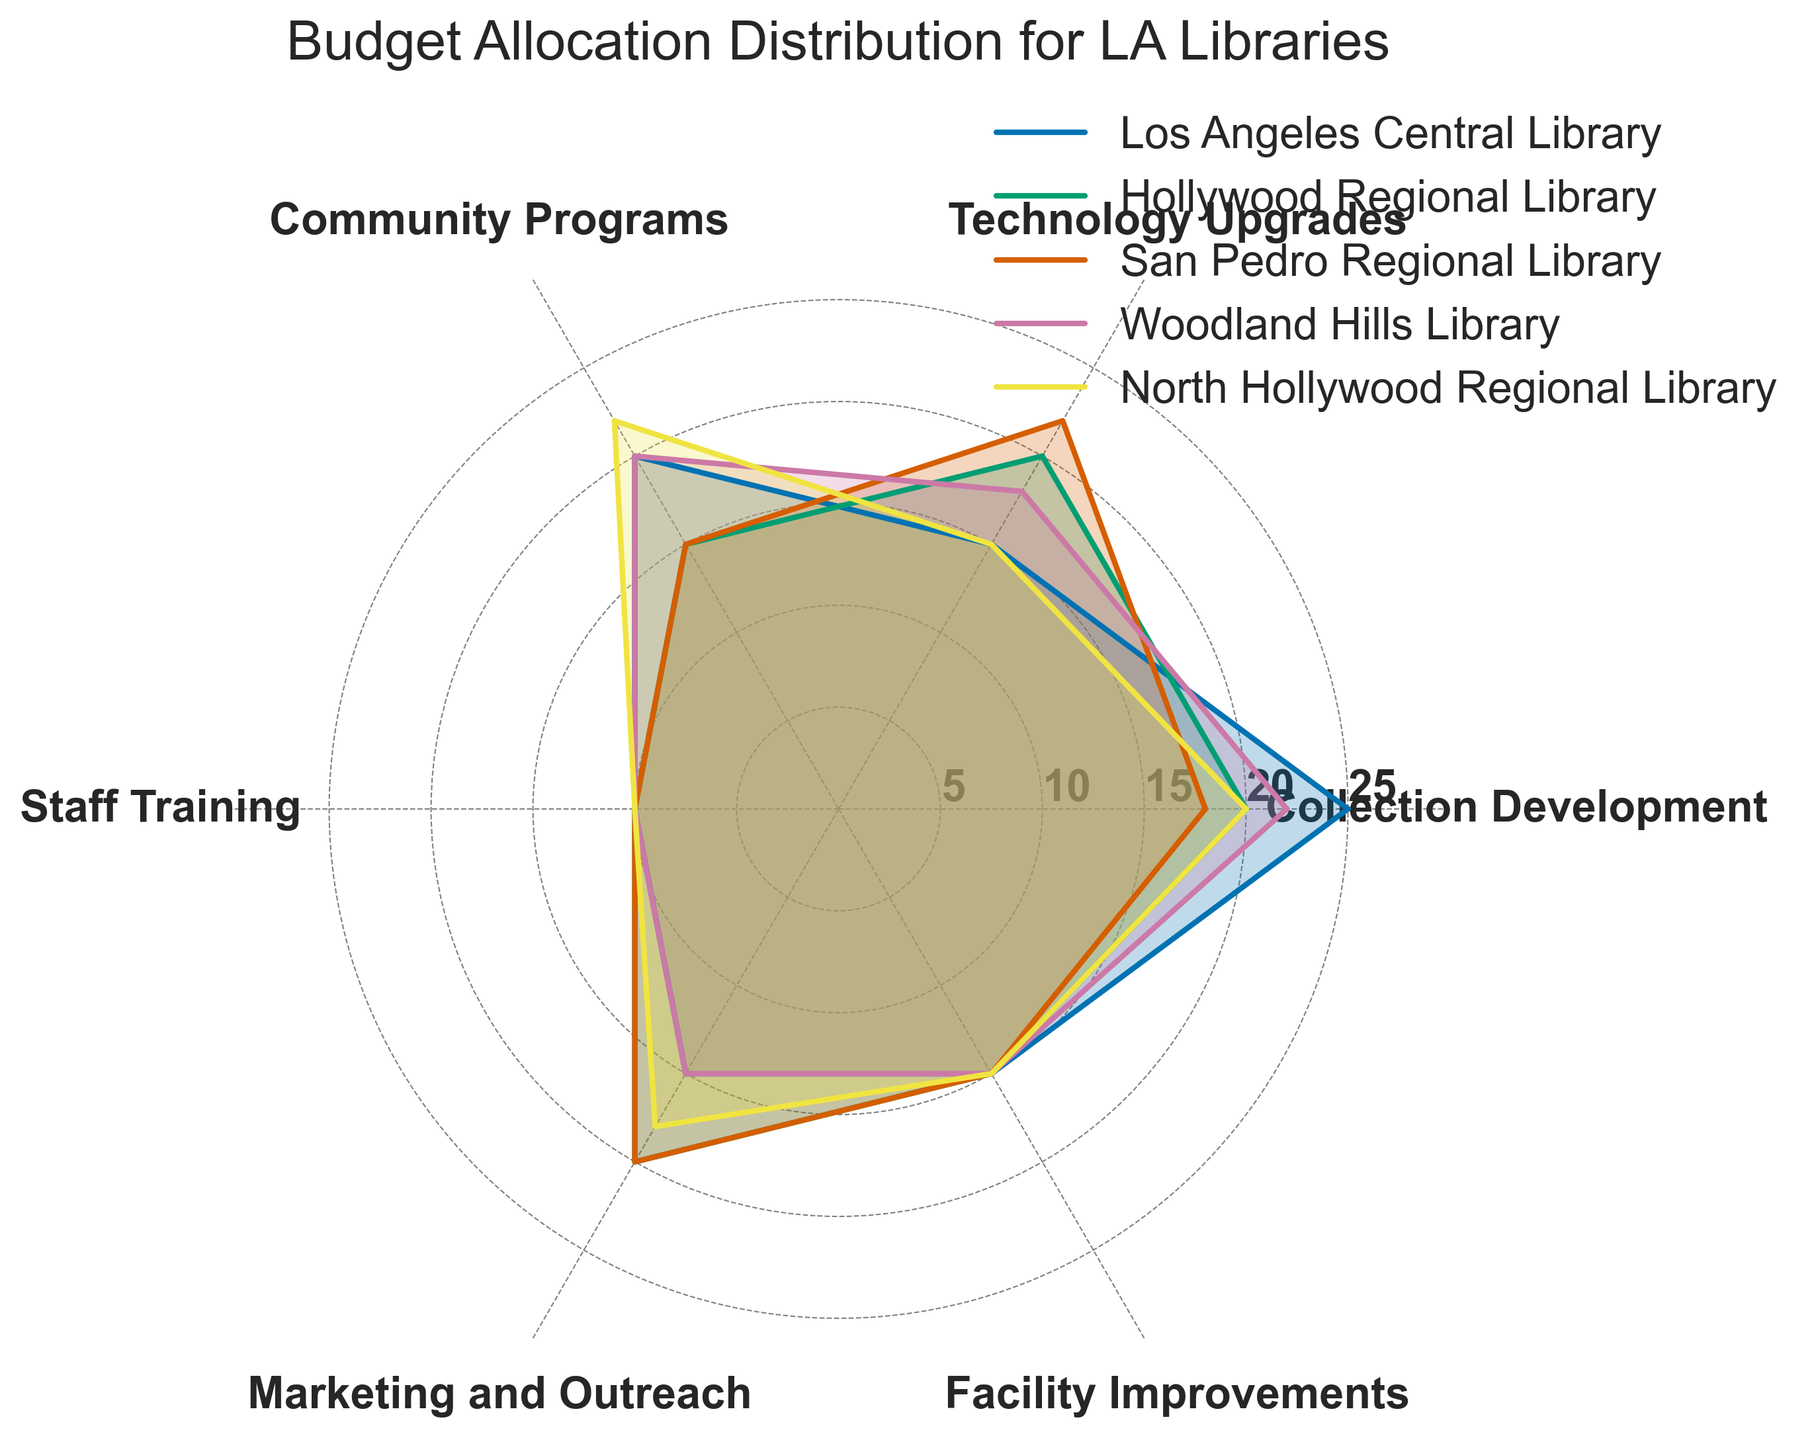What's the overall title of the radar chart? The title of the radar chart is prominently displayed at the top of the figure. It summarizes the main focus of the data presented in the chart.
Answer: Budget Allocation Distribution for LA Libraries Which library has the highest allocation for Community Programs? Look at the sections labeled 'Community Programs' and compare the values for each library. The highest allocation can be determined by the longest line extending from the center in that section.
Answer: North Hollywood Regional Library Which two categories have the same allocation for all libraries? Examine each category and their respective values across all libraries. Identify the categories where the line lengths are identical for every library in those sections.
Answer: Staff Training and Facility Improvements What is the average budget allocation for Technology Upgrades across all libraries? Calculate the average by summing up the budget allocations for Technology Upgrades from all libraries and dividing by the number of libraries. (15+20+22+18+15)/5 = 18
Answer: 18 Which library allocates the most to Marketing and Outreach? Compare the Marketing and Outreach sections and identify which library has the longest line extending in that category.
Answer: Hollywood Regional Library and San Pedro Regional Library For Woodland Hills Library, which two categories have the highest allocations? Look at the Woodland Hills Library's allocations and identify the two categories with the longest line segments.
Answer: Collection Development and Community Programs Between Los Angeles Central Library and Hollywood Regional Library, which one allocates more budget to Technology Upgrades? Compare the lengths of the line segments for Technology Upgrades for these two libraries.
Answer: Hollywood Regional Library What is the total budget allocation for Los Angeles Central Library and Woodland Hills Library in Facility Improvements? Add the values for Facility Improvements for both libraries. (15 + 15) = 30
Answer: 30 Which two programs have an equal budget allocation in North Hollywood Regional Library, besides Staff Training and Facility Improvements? Examine the budget allocations for North Hollywood Regional Library and identify any other two categories with equal values.
Answer: Technology Upgrades and Community Programs Which library has the lowest allocation for Collection Development? Look at the ‘Collection Development’ category and find the shortest line segment.
Answer: San Pedro Regional Library 